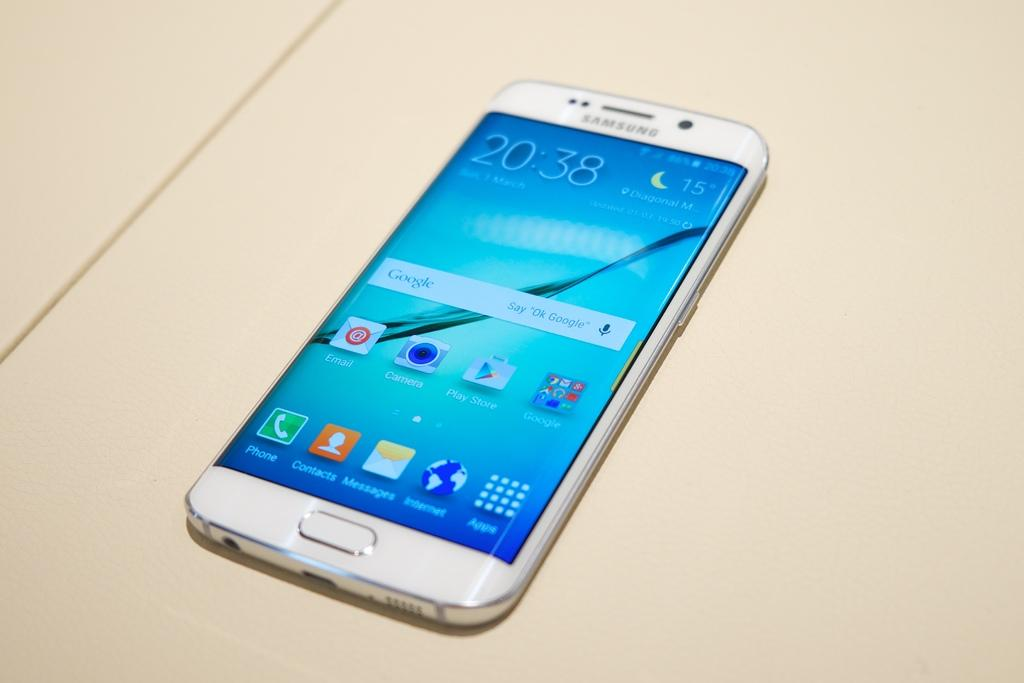<image>
Write a terse but informative summary of the picture. The front side of a white samsung branded cell phone with app icon for google play store. 